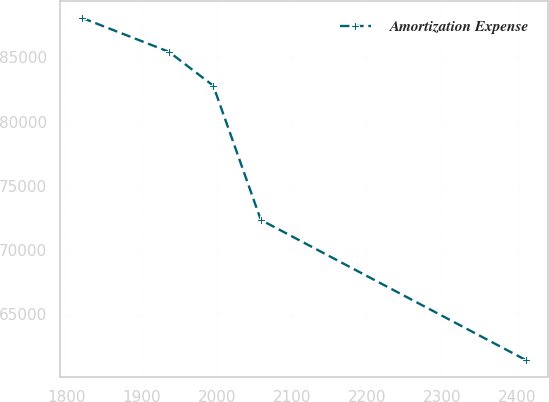Convert chart. <chart><loc_0><loc_0><loc_500><loc_500><line_chart><ecel><fcel>Amortization Expense<nl><fcel>1821.04<fcel>88064.3<nl><fcel>1936.48<fcel>85427.9<nl><fcel>1995.48<fcel>82791.6<nl><fcel>2058.68<fcel>72356.3<nl><fcel>2411.01<fcel>61456.7<nl></chart> 